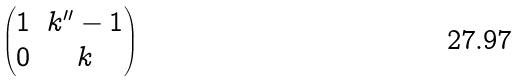Convert formula to latex. <formula><loc_0><loc_0><loc_500><loc_500>\begin{pmatrix} 1 & k ^ { \prime \prime } - 1 \\ 0 & k \\ \end{pmatrix}</formula> 